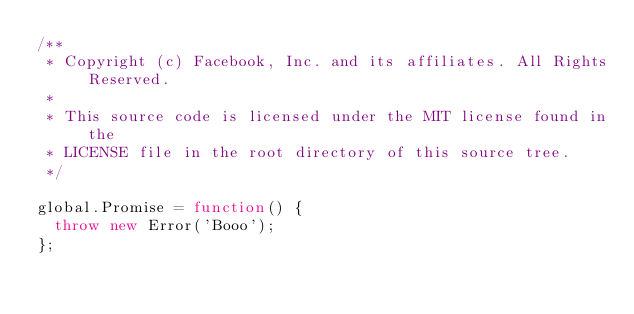<code> <loc_0><loc_0><loc_500><loc_500><_JavaScript_>/**
 * Copyright (c) Facebook, Inc. and its affiliates. All Rights Reserved.
 *
 * This source code is licensed under the MIT license found in the
 * LICENSE file in the root directory of this source tree.
 */

global.Promise = function() {
  throw new Error('Booo');
};
</code> 